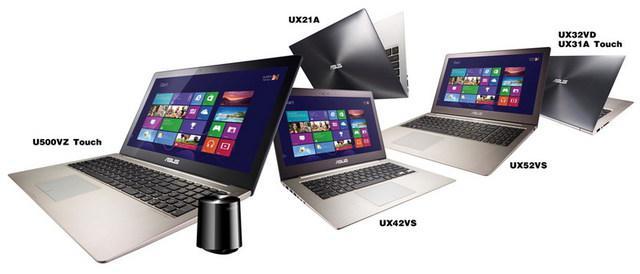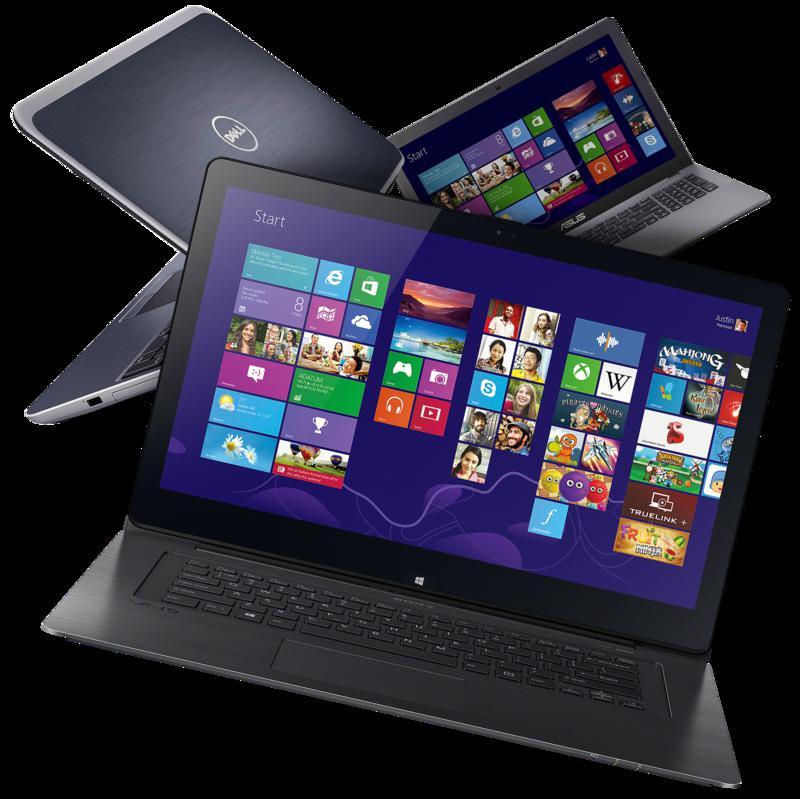The first image is the image on the left, the second image is the image on the right. Evaluate the accuracy of this statement regarding the images: "There are five open laptops with at least two turned away.". Is it true? Answer yes or no. Yes. The first image is the image on the left, the second image is the image on the right. For the images shown, is this caption "The right image shows exactly one laptop with a picture on the back facing outward, and the left image includes at least two laptops that are at least partly open." true? Answer yes or no. No. 